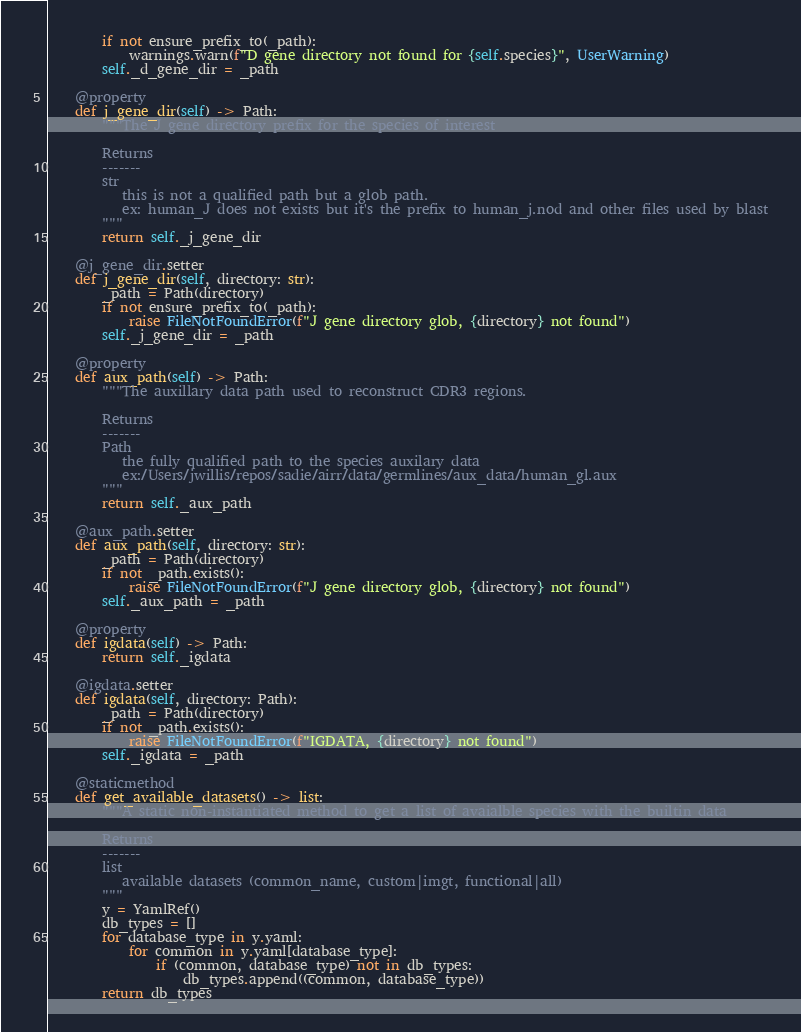<code> <loc_0><loc_0><loc_500><loc_500><_Python_>        if not ensure_prefix_to(_path):
            warnings.warn(f"D gene directory not found for {self.species}", UserWarning)
        self._d_gene_dir = _path

    @property
    def j_gene_dir(self) -> Path:
        """The J gene directory prefix for the species of interest

        Returns
        -------
        str
           this is not a qualified path but a glob path.
           ex: human_J does not exists but it's the prefix to human_j.nod and other files used by blast
        """
        return self._j_gene_dir

    @j_gene_dir.setter
    def j_gene_dir(self, directory: str):
        _path = Path(directory)
        if not ensure_prefix_to(_path):
            raise FileNotFoundError(f"J gene directory glob, {directory} not found")
        self._j_gene_dir = _path

    @property
    def aux_path(self) -> Path:
        """The auxillary data path used to reconstruct CDR3 regions.

        Returns
        -------
        Path
           the fully qualified path to the species auxilary data
           ex:/Users/jwillis/repos/sadie/airr/data/germlines/aux_data/human_gl.aux
        """
        return self._aux_path

    @aux_path.setter
    def aux_path(self, directory: str):
        _path = Path(directory)
        if not _path.exists():
            raise FileNotFoundError(f"J gene directory glob, {directory} not found")
        self._aux_path = _path

    @property
    def igdata(self) -> Path:
        return self._igdata

    @igdata.setter
    def igdata(self, directory: Path):
        _path = Path(directory)
        if not _path.exists():
            raise FileNotFoundError(f"IGDATA, {directory} not found")
        self._igdata = _path

    @staticmethod
    def get_available_datasets() -> list:
        """A static non-instantiated method to get a list of avaialble species with the builtin data

        Returns
        -------
        list
           available datasets (common_name, custom|imgt, functional|all)
        """
        y = YamlRef()
        db_types = []
        for database_type in y.yaml:
            for common in y.yaml[database_type]:
                if (common, database_type) not in db_types:
                    db_types.append((common, database_type))
        return db_types
</code> 